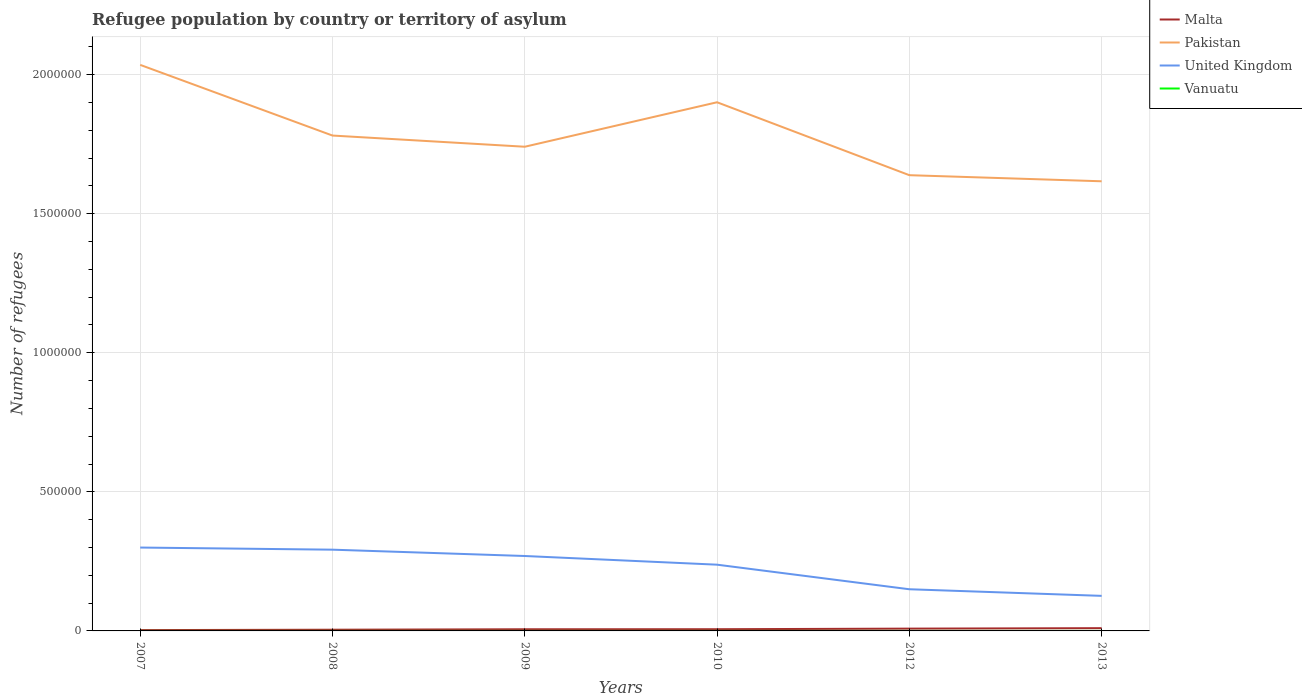How many different coloured lines are there?
Offer a terse response. 4. Does the line corresponding to Pakistan intersect with the line corresponding to Malta?
Your response must be concise. No. Across all years, what is the maximum number of refugees in Malta?
Offer a terse response. 3000. What is the total number of refugees in United Kingdom in the graph?
Offer a terse response. 6.16e+04. What is the difference between the highest and the second highest number of refugees in Pakistan?
Give a very brief answer. 4.19e+05. What is the difference between the highest and the lowest number of refugees in Pakistan?
Provide a short and direct response. 2. Is the number of refugees in United Kingdom strictly greater than the number of refugees in Vanuatu over the years?
Offer a terse response. No. How many lines are there?
Your answer should be very brief. 4. How many years are there in the graph?
Your answer should be compact. 6. Are the values on the major ticks of Y-axis written in scientific E-notation?
Offer a terse response. No. Where does the legend appear in the graph?
Provide a succinct answer. Top right. How are the legend labels stacked?
Keep it short and to the point. Vertical. What is the title of the graph?
Your answer should be very brief. Refugee population by country or territory of asylum. What is the label or title of the X-axis?
Your answer should be compact. Years. What is the label or title of the Y-axis?
Offer a terse response. Number of refugees. What is the Number of refugees in Malta in 2007?
Offer a very short reply. 3000. What is the Number of refugees in Pakistan in 2007?
Provide a short and direct response. 2.04e+06. What is the Number of refugees in United Kingdom in 2007?
Offer a terse response. 3.00e+05. What is the Number of refugees of Vanuatu in 2007?
Your answer should be very brief. 1. What is the Number of refugees of Malta in 2008?
Give a very brief answer. 4332. What is the Number of refugees in Pakistan in 2008?
Keep it short and to the point. 1.78e+06. What is the Number of refugees in United Kingdom in 2008?
Your answer should be very brief. 2.92e+05. What is the Number of refugees in Vanuatu in 2008?
Provide a short and direct response. 3. What is the Number of refugees of Malta in 2009?
Your response must be concise. 5955. What is the Number of refugees in Pakistan in 2009?
Your answer should be very brief. 1.74e+06. What is the Number of refugees of United Kingdom in 2009?
Your answer should be compact. 2.69e+05. What is the Number of refugees in Malta in 2010?
Your answer should be very brief. 6136. What is the Number of refugees of Pakistan in 2010?
Offer a terse response. 1.90e+06. What is the Number of refugees of United Kingdom in 2010?
Offer a very short reply. 2.38e+05. What is the Number of refugees of Malta in 2012?
Your response must be concise. 8248. What is the Number of refugees of Pakistan in 2012?
Provide a short and direct response. 1.64e+06. What is the Number of refugees in United Kingdom in 2012?
Ensure brevity in your answer.  1.50e+05. What is the Number of refugees of Vanuatu in 2012?
Make the answer very short. 2. What is the Number of refugees of Malta in 2013?
Give a very brief answer. 9906. What is the Number of refugees of Pakistan in 2013?
Give a very brief answer. 1.62e+06. What is the Number of refugees of United Kingdom in 2013?
Your answer should be compact. 1.26e+05. Across all years, what is the maximum Number of refugees in Malta?
Provide a short and direct response. 9906. Across all years, what is the maximum Number of refugees in Pakistan?
Offer a terse response. 2.04e+06. Across all years, what is the maximum Number of refugees of United Kingdom?
Provide a succinct answer. 3.00e+05. Across all years, what is the maximum Number of refugees of Vanuatu?
Make the answer very short. 4. Across all years, what is the minimum Number of refugees of Malta?
Ensure brevity in your answer.  3000. Across all years, what is the minimum Number of refugees of Pakistan?
Provide a short and direct response. 1.62e+06. Across all years, what is the minimum Number of refugees of United Kingdom?
Offer a terse response. 1.26e+05. Across all years, what is the minimum Number of refugees in Vanuatu?
Keep it short and to the point. 1. What is the total Number of refugees in Malta in the graph?
Offer a very short reply. 3.76e+04. What is the total Number of refugees of Pakistan in the graph?
Your response must be concise. 1.07e+07. What is the total Number of refugees of United Kingdom in the graph?
Your answer should be compact. 1.38e+06. What is the difference between the Number of refugees in Malta in 2007 and that in 2008?
Provide a short and direct response. -1332. What is the difference between the Number of refugees of Pakistan in 2007 and that in 2008?
Make the answer very short. 2.54e+05. What is the difference between the Number of refugees of United Kingdom in 2007 and that in 2008?
Ensure brevity in your answer.  7621. What is the difference between the Number of refugees in Vanuatu in 2007 and that in 2008?
Offer a terse response. -2. What is the difference between the Number of refugees in Malta in 2007 and that in 2009?
Keep it short and to the point. -2955. What is the difference between the Number of refugees of Pakistan in 2007 and that in 2009?
Your response must be concise. 2.94e+05. What is the difference between the Number of refugees in United Kingdom in 2007 and that in 2009?
Your answer should be very brief. 3.04e+04. What is the difference between the Number of refugees in Vanuatu in 2007 and that in 2009?
Give a very brief answer. -3. What is the difference between the Number of refugees of Malta in 2007 and that in 2010?
Ensure brevity in your answer.  -3136. What is the difference between the Number of refugees of Pakistan in 2007 and that in 2010?
Keep it short and to the point. 1.34e+05. What is the difference between the Number of refugees of United Kingdom in 2007 and that in 2010?
Your answer should be very brief. 6.16e+04. What is the difference between the Number of refugees of Vanuatu in 2007 and that in 2010?
Your response must be concise. -3. What is the difference between the Number of refugees of Malta in 2007 and that in 2012?
Your answer should be very brief. -5248. What is the difference between the Number of refugees of Pakistan in 2007 and that in 2012?
Offer a very short reply. 3.97e+05. What is the difference between the Number of refugees in United Kingdom in 2007 and that in 2012?
Your answer should be very brief. 1.50e+05. What is the difference between the Number of refugees of Malta in 2007 and that in 2013?
Provide a succinct answer. -6906. What is the difference between the Number of refugees in Pakistan in 2007 and that in 2013?
Give a very brief answer. 4.19e+05. What is the difference between the Number of refugees of United Kingdom in 2007 and that in 2013?
Offer a very short reply. 1.74e+05. What is the difference between the Number of refugees of Vanuatu in 2007 and that in 2013?
Your answer should be compact. -1. What is the difference between the Number of refugees in Malta in 2008 and that in 2009?
Your answer should be compact. -1623. What is the difference between the Number of refugees of Pakistan in 2008 and that in 2009?
Offer a terse response. 4.02e+04. What is the difference between the Number of refugees of United Kingdom in 2008 and that in 2009?
Your answer should be very brief. 2.27e+04. What is the difference between the Number of refugees in Vanuatu in 2008 and that in 2009?
Your answer should be compact. -1. What is the difference between the Number of refugees of Malta in 2008 and that in 2010?
Make the answer very short. -1804. What is the difference between the Number of refugees in Pakistan in 2008 and that in 2010?
Give a very brief answer. -1.20e+05. What is the difference between the Number of refugees of United Kingdom in 2008 and that in 2010?
Offer a very short reply. 5.39e+04. What is the difference between the Number of refugees in Vanuatu in 2008 and that in 2010?
Give a very brief answer. -1. What is the difference between the Number of refugees of Malta in 2008 and that in 2012?
Offer a very short reply. -3916. What is the difference between the Number of refugees of Pakistan in 2008 and that in 2012?
Offer a terse response. 1.42e+05. What is the difference between the Number of refugees in United Kingdom in 2008 and that in 2012?
Your answer should be compact. 1.42e+05. What is the difference between the Number of refugees of Malta in 2008 and that in 2013?
Provide a short and direct response. -5574. What is the difference between the Number of refugees in Pakistan in 2008 and that in 2013?
Provide a short and direct response. 1.64e+05. What is the difference between the Number of refugees in United Kingdom in 2008 and that in 2013?
Offer a terse response. 1.66e+05. What is the difference between the Number of refugees of Vanuatu in 2008 and that in 2013?
Provide a short and direct response. 1. What is the difference between the Number of refugees of Malta in 2009 and that in 2010?
Keep it short and to the point. -181. What is the difference between the Number of refugees of Pakistan in 2009 and that in 2010?
Your answer should be very brief. -1.60e+05. What is the difference between the Number of refugees of United Kingdom in 2009 and that in 2010?
Your answer should be compact. 3.12e+04. What is the difference between the Number of refugees of Malta in 2009 and that in 2012?
Provide a short and direct response. -2293. What is the difference between the Number of refugees of Pakistan in 2009 and that in 2012?
Offer a very short reply. 1.02e+05. What is the difference between the Number of refugees of United Kingdom in 2009 and that in 2012?
Ensure brevity in your answer.  1.20e+05. What is the difference between the Number of refugees in Malta in 2009 and that in 2013?
Offer a very short reply. -3951. What is the difference between the Number of refugees of Pakistan in 2009 and that in 2013?
Give a very brief answer. 1.24e+05. What is the difference between the Number of refugees of United Kingdom in 2009 and that in 2013?
Keep it short and to the point. 1.43e+05. What is the difference between the Number of refugees of Malta in 2010 and that in 2012?
Your answer should be compact. -2112. What is the difference between the Number of refugees of Pakistan in 2010 and that in 2012?
Your answer should be very brief. 2.62e+05. What is the difference between the Number of refugees of United Kingdom in 2010 and that in 2012?
Make the answer very short. 8.84e+04. What is the difference between the Number of refugees of Malta in 2010 and that in 2013?
Keep it short and to the point. -3770. What is the difference between the Number of refugees in Pakistan in 2010 and that in 2013?
Provide a short and direct response. 2.84e+05. What is the difference between the Number of refugees in United Kingdom in 2010 and that in 2013?
Your response must be concise. 1.12e+05. What is the difference between the Number of refugees of Vanuatu in 2010 and that in 2013?
Offer a terse response. 2. What is the difference between the Number of refugees in Malta in 2012 and that in 2013?
Ensure brevity in your answer.  -1658. What is the difference between the Number of refugees of Pakistan in 2012 and that in 2013?
Your answer should be compact. 2.19e+04. What is the difference between the Number of refugees in United Kingdom in 2012 and that in 2013?
Ensure brevity in your answer.  2.37e+04. What is the difference between the Number of refugees in Malta in 2007 and the Number of refugees in Pakistan in 2008?
Your answer should be compact. -1.78e+06. What is the difference between the Number of refugees of Malta in 2007 and the Number of refugees of United Kingdom in 2008?
Offer a very short reply. -2.89e+05. What is the difference between the Number of refugees in Malta in 2007 and the Number of refugees in Vanuatu in 2008?
Make the answer very short. 2997. What is the difference between the Number of refugees of Pakistan in 2007 and the Number of refugees of United Kingdom in 2008?
Your answer should be very brief. 1.74e+06. What is the difference between the Number of refugees of Pakistan in 2007 and the Number of refugees of Vanuatu in 2008?
Provide a succinct answer. 2.04e+06. What is the difference between the Number of refugees in United Kingdom in 2007 and the Number of refugees in Vanuatu in 2008?
Provide a succinct answer. 3.00e+05. What is the difference between the Number of refugees in Malta in 2007 and the Number of refugees in Pakistan in 2009?
Make the answer very short. -1.74e+06. What is the difference between the Number of refugees of Malta in 2007 and the Number of refugees of United Kingdom in 2009?
Offer a terse response. -2.66e+05. What is the difference between the Number of refugees in Malta in 2007 and the Number of refugees in Vanuatu in 2009?
Make the answer very short. 2996. What is the difference between the Number of refugees in Pakistan in 2007 and the Number of refugees in United Kingdom in 2009?
Offer a terse response. 1.77e+06. What is the difference between the Number of refugees in Pakistan in 2007 and the Number of refugees in Vanuatu in 2009?
Offer a very short reply. 2.04e+06. What is the difference between the Number of refugees of United Kingdom in 2007 and the Number of refugees of Vanuatu in 2009?
Your answer should be very brief. 3.00e+05. What is the difference between the Number of refugees in Malta in 2007 and the Number of refugees in Pakistan in 2010?
Your answer should be very brief. -1.90e+06. What is the difference between the Number of refugees of Malta in 2007 and the Number of refugees of United Kingdom in 2010?
Offer a terse response. -2.35e+05. What is the difference between the Number of refugees of Malta in 2007 and the Number of refugees of Vanuatu in 2010?
Provide a short and direct response. 2996. What is the difference between the Number of refugees in Pakistan in 2007 and the Number of refugees in United Kingdom in 2010?
Ensure brevity in your answer.  1.80e+06. What is the difference between the Number of refugees in Pakistan in 2007 and the Number of refugees in Vanuatu in 2010?
Your response must be concise. 2.04e+06. What is the difference between the Number of refugees in United Kingdom in 2007 and the Number of refugees in Vanuatu in 2010?
Keep it short and to the point. 3.00e+05. What is the difference between the Number of refugees in Malta in 2007 and the Number of refugees in Pakistan in 2012?
Your response must be concise. -1.64e+06. What is the difference between the Number of refugees in Malta in 2007 and the Number of refugees in United Kingdom in 2012?
Offer a very short reply. -1.47e+05. What is the difference between the Number of refugees in Malta in 2007 and the Number of refugees in Vanuatu in 2012?
Offer a terse response. 2998. What is the difference between the Number of refugees in Pakistan in 2007 and the Number of refugees in United Kingdom in 2012?
Offer a very short reply. 1.89e+06. What is the difference between the Number of refugees of Pakistan in 2007 and the Number of refugees of Vanuatu in 2012?
Your answer should be very brief. 2.04e+06. What is the difference between the Number of refugees in United Kingdom in 2007 and the Number of refugees in Vanuatu in 2012?
Ensure brevity in your answer.  3.00e+05. What is the difference between the Number of refugees of Malta in 2007 and the Number of refugees of Pakistan in 2013?
Your response must be concise. -1.61e+06. What is the difference between the Number of refugees of Malta in 2007 and the Number of refugees of United Kingdom in 2013?
Offer a terse response. -1.23e+05. What is the difference between the Number of refugees in Malta in 2007 and the Number of refugees in Vanuatu in 2013?
Ensure brevity in your answer.  2998. What is the difference between the Number of refugees in Pakistan in 2007 and the Number of refugees in United Kingdom in 2013?
Ensure brevity in your answer.  1.91e+06. What is the difference between the Number of refugees in Pakistan in 2007 and the Number of refugees in Vanuatu in 2013?
Your answer should be very brief. 2.04e+06. What is the difference between the Number of refugees of United Kingdom in 2007 and the Number of refugees of Vanuatu in 2013?
Keep it short and to the point. 3.00e+05. What is the difference between the Number of refugees in Malta in 2008 and the Number of refugees in Pakistan in 2009?
Your answer should be compact. -1.74e+06. What is the difference between the Number of refugees in Malta in 2008 and the Number of refugees in United Kingdom in 2009?
Your response must be concise. -2.65e+05. What is the difference between the Number of refugees in Malta in 2008 and the Number of refugees in Vanuatu in 2009?
Provide a succinct answer. 4328. What is the difference between the Number of refugees in Pakistan in 2008 and the Number of refugees in United Kingdom in 2009?
Keep it short and to the point. 1.51e+06. What is the difference between the Number of refugees in Pakistan in 2008 and the Number of refugees in Vanuatu in 2009?
Provide a succinct answer. 1.78e+06. What is the difference between the Number of refugees in United Kingdom in 2008 and the Number of refugees in Vanuatu in 2009?
Your response must be concise. 2.92e+05. What is the difference between the Number of refugees in Malta in 2008 and the Number of refugees in Pakistan in 2010?
Provide a short and direct response. -1.90e+06. What is the difference between the Number of refugees of Malta in 2008 and the Number of refugees of United Kingdom in 2010?
Your answer should be very brief. -2.34e+05. What is the difference between the Number of refugees in Malta in 2008 and the Number of refugees in Vanuatu in 2010?
Offer a very short reply. 4328. What is the difference between the Number of refugees in Pakistan in 2008 and the Number of refugees in United Kingdom in 2010?
Give a very brief answer. 1.54e+06. What is the difference between the Number of refugees in Pakistan in 2008 and the Number of refugees in Vanuatu in 2010?
Make the answer very short. 1.78e+06. What is the difference between the Number of refugees in United Kingdom in 2008 and the Number of refugees in Vanuatu in 2010?
Make the answer very short. 2.92e+05. What is the difference between the Number of refugees in Malta in 2008 and the Number of refugees in Pakistan in 2012?
Your response must be concise. -1.63e+06. What is the difference between the Number of refugees in Malta in 2008 and the Number of refugees in United Kingdom in 2012?
Provide a succinct answer. -1.45e+05. What is the difference between the Number of refugees of Malta in 2008 and the Number of refugees of Vanuatu in 2012?
Ensure brevity in your answer.  4330. What is the difference between the Number of refugees in Pakistan in 2008 and the Number of refugees in United Kingdom in 2012?
Keep it short and to the point. 1.63e+06. What is the difference between the Number of refugees of Pakistan in 2008 and the Number of refugees of Vanuatu in 2012?
Your response must be concise. 1.78e+06. What is the difference between the Number of refugees of United Kingdom in 2008 and the Number of refugees of Vanuatu in 2012?
Provide a succinct answer. 2.92e+05. What is the difference between the Number of refugees in Malta in 2008 and the Number of refugees in Pakistan in 2013?
Make the answer very short. -1.61e+06. What is the difference between the Number of refugees in Malta in 2008 and the Number of refugees in United Kingdom in 2013?
Offer a terse response. -1.22e+05. What is the difference between the Number of refugees in Malta in 2008 and the Number of refugees in Vanuatu in 2013?
Offer a very short reply. 4330. What is the difference between the Number of refugees of Pakistan in 2008 and the Number of refugees of United Kingdom in 2013?
Provide a short and direct response. 1.65e+06. What is the difference between the Number of refugees in Pakistan in 2008 and the Number of refugees in Vanuatu in 2013?
Ensure brevity in your answer.  1.78e+06. What is the difference between the Number of refugees of United Kingdom in 2008 and the Number of refugees of Vanuatu in 2013?
Ensure brevity in your answer.  2.92e+05. What is the difference between the Number of refugees of Malta in 2009 and the Number of refugees of Pakistan in 2010?
Offer a terse response. -1.89e+06. What is the difference between the Number of refugees in Malta in 2009 and the Number of refugees in United Kingdom in 2010?
Offer a terse response. -2.32e+05. What is the difference between the Number of refugees of Malta in 2009 and the Number of refugees of Vanuatu in 2010?
Your response must be concise. 5951. What is the difference between the Number of refugees of Pakistan in 2009 and the Number of refugees of United Kingdom in 2010?
Give a very brief answer. 1.50e+06. What is the difference between the Number of refugees in Pakistan in 2009 and the Number of refugees in Vanuatu in 2010?
Make the answer very short. 1.74e+06. What is the difference between the Number of refugees of United Kingdom in 2009 and the Number of refugees of Vanuatu in 2010?
Your answer should be very brief. 2.69e+05. What is the difference between the Number of refugees of Malta in 2009 and the Number of refugees of Pakistan in 2012?
Provide a succinct answer. -1.63e+06. What is the difference between the Number of refugees of Malta in 2009 and the Number of refugees of United Kingdom in 2012?
Ensure brevity in your answer.  -1.44e+05. What is the difference between the Number of refugees in Malta in 2009 and the Number of refugees in Vanuatu in 2012?
Make the answer very short. 5953. What is the difference between the Number of refugees of Pakistan in 2009 and the Number of refugees of United Kingdom in 2012?
Provide a succinct answer. 1.59e+06. What is the difference between the Number of refugees in Pakistan in 2009 and the Number of refugees in Vanuatu in 2012?
Provide a short and direct response. 1.74e+06. What is the difference between the Number of refugees of United Kingdom in 2009 and the Number of refugees of Vanuatu in 2012?
Offer a terse response. 2.69e+05. What is the difference between the Number of refugees in Malta in 2009 and the Number of refugees in Pakistan in 2013?
Provide a succinct answer. -1.61e+06. What is the difference between the Number of refugees in Malta in 2009 and the Number of refugees in United Kingdom in 2013?
Your response must be concise. -1.20e+05. What is the difference between the Number of refugees of Malta in 2009 and the Number of refugees of Vanuatu in 2013?
Your answer should be compact. 5953. What is the difference between the Number of refugees in Pakistan in 2009 and the Number of refugees in United Kingdom in 2013?
Give a very brief answer. 1.61e+06. What is the difference between the Number of refugees in Pakistan in 2009 and the Number of refugees in Vanuatu in 2013?
Offer a terse response. 1.74e+06. What is the difference between the Number of refugees in United Kingdom in 2009 and the Number of refugees in Vanuatu in 2013?
Offer a very short reply. 2.69e+05. What is the difference between the Number of refugees in Malta in 2010 and the Number of refugees in Pakistan in 2012?
Your answer should be very brief. -1.63e+06. What is the difference between the Number of refugees of Malta in 2010 and the Number of refugees of United Kingdom in 2012?
Offer a terse response. -1.44e+05. What is the difference between the Number of refugees of Malta in 2010 and the Number of refugees of Vanuatu in 2012?
Ensure brevity in your answer.  6134. What is the difference between the Number of refugees of Pakistan in 2010 and the Number of refugees of United Kingdom in 2012?
Keep it short and to the point. 1.75e+06. What is the difference between the Number of refugees of Pakistan in 2010 and the Number of refugees of Vanuatu in 2012?
Make the answer very short. 1.90e+06. What is the difference between the Number of refugees in United Kingdom in 2010 and the Number of refugees in Vanuatu in 2012?
Offer a terse response. 2.38e+05. What is the difference between the Number of refugees of Malta in 2010 and the Number of refugees of Pakistan in 2013?
Provide a succinct answer. -1.61e+06. What is the difference between the Number of refugees in Malta in 2010 and the Number of refugees in United Kingdom in 2013?
Make the answer very short. -1.20e+05. What is the difference between the Number of refugees of Malta in 2010 and the Number of refugees of Vanuatu in 2013?
Provide a short and direct response. 6134. What is the difference between the Number of refugees in Pakistan in 2010 and the Number of refugees in United Kingdom in 2013?
Ensure brevity in your answer.  1.77e+06. What is the difference between the Number of refugees in Pakistan in 2010 and the Number of refugees in Vanuatu in 2013?
Your answer should be compact. 1.90e+06. What is the difference between the Number of refugees in United Kingdom in 2010 and the Number of refugees in Vanuatu in 2013?
Your answer should be compact. 2.38e+05. What is the difference between the Number of refugees of Malta in 2012 and the Number of refugees of Pakistan in 2013?
Provide a short and direct response. -1.61e+06. What is the difference between the Number of refugees of Malta in 2012 and the Number of refugees of United Kingdom in 2013?
Keep it short and to the point. -1.18e+05. What is the difference between the Number of refugees of Malta in 2012 and the Number of refugees of Vanuatu in 2013?
Offer a very short reply. 8246. What is the difference between the Number of refugees in Pakistan in 2012 and the Number of refugees in United Kingdom in 2013?
Your response must be concise. 1.51e+06. What is the difference between the Number of refugees of Pakistan in 2012 and the Number of refugees of Vanuatu in 2013?
Provide a succinct answer. 1.64e+06. What is the difference between the Number of refugees in United Kingdom in 2012 and the Number of refugees in Vanuatu in 2013?
Keep it short and to the point. 1.50e+05. What is the average Number of refugees in Malta per year?
Offer a very short reply. 6262.83. What is the average Number of refugees in Pakistan per year?
Offer a terse response. 1.79e+06. What is the average Number of refugees of United Kingdom per year?
Your response must be concise. 2.29e+05. What is the average Number of refugees in Vanuatu per year?
Offer a very short reply. 2.67. In the year 2007, what is the difference between the Number of refugees in Malta and Number of refugees in Pakistan?
Offer a terse response. -2.03e+06. In the year 2007, what is the difference between the Number of refugees in Malta and Number of refugees in United Kingdom?
Provide a succinct answer. -2.97e+05. In the year 2007, what is the difference between the Number of refugees of Malta and Number of refugees of Vanuatu?
Your answer should be very brief. 2999. In the year 2007, what is the difference between the Number of refugees of Pakistan and Number of refugees of United Kingdom?
Make the answer very short. 1.74e+06. In the year 2007, what is the difference between the Number of refugees in Pakistan and Number of refugees in Vanuatu?
Keep it short and to the point. 2.04e+06. In the year 2007, what is the difference between the Number of refugees of United Kingdom and Number of refugees of Vanuatu?
Offer a very short reply. 3.00e+05. In the year 2008, what is the difference between the Number of refugees in Malta and Number of refugees in Pakistan?
Offer a terse response. -1.78e+06. In the year 2008, what is the difference between the Number of refugees of Malta and Number of refugees of United Kingdom?
Give a very brief answer. -2.88e+05. In the year 2008, what is the difference between the Number of refugees in Malta and Number of refugees in Vanuatu?
Make the answer very short. 4329. In the year 2008, what is the difference between the Number of refugees in Pakistan and Number of refugees in United Kingdom?
Ensure brevity in your answer.  1.49e+06. In the year 2008, what is the difference between the Number of refugees of Pakistan and Number of refugees of Vanuatu?
Your response must be concise. 1.78e+06. In the year 2008, what is the difference between the Number of refugees of United Kingdom and Number of refugees of Vanuatu?
Offer a terse response. 2.92e+05. In the year 2009, what is the difference between the Number of refugees in Malta and Number of refugees in Pakistan?
Your answer should be compact. -1.73e+06. In the year 2009, what is the difference between the Number of refugees of Malta and Number of refugees of United Kingdom?
Offer a terse response. -2.63e+05. In the year 2009, what is the difference between the Number of refugees of Malta and Number of refugees of Vanuatu?
Keep it short and to the point. 5951. In the year 2009, what is the difference between the Number of refugees of Pakistan and Number of refugees of United Kingdom?
Provide a succinct answer. 1.47e+06. In the year 2009, what is the difference between the Number of refugees of Pakistan and Number of refugees of Vanuatu?
Ensure brevity in your answer.  1.74e+06. In the year 2009, what is the difference between the Number of refugees of United Kingdom and Number of refugees of Vanuatu?
Offer a terse response. 2.69e+05. In the year 2010, what is the difference between the Number of refugees in Malta and Number of refugees in Pakistan?
Your answer should be compact. -1.89e+06. In the year 2010, what is the difference between the Number of refugees in Malta and Number of refugees in United Kingdom?
Give a very brief answer. -2.32e+05. In the year 2010, what is the difference between the Number of refugees in Malta and Number of refugees in Vanuatu?
Offer a terse response. 6132. In the year 2010, what is the difference between the Number of refugees of Pakistan and Number of refugees of United Kingdom?
Offer a terse response. 1.66e+06. In the year 2010, what is the difference between the Number of refugees in Pakistan and Number of refugees in Vanuatu?
Provide a succinct answer. 1.90e+06. In the year 2010, what is the difference between the Number of refugees in United Kingdom and Number of refugees in Vanuatu?
Your response must be concise. 2.38e+05. In the year 2012, what is the difference between the Number of refugees in Malta and Number of refugees in Pakistan?
Give a very brief answer. -1.63e+06. In the year 2012, what is the difference between the Number of refugees of Malta and Number of refugees of United Kingdom?
Provide a succinct answer. -1.42e+05. In the year 2012, what is the difference between the Number of refugees in Malta and Number of refugees in Vanuatu?
Make the answer very short. 8246. In the year 2012, what is the difference between the Number of refugees in Pakistan and Number of refugees in United Kingdom?
Make the answer very short. 1.49e+06. In the year 2012, what is the difference between the Number of refugees in Pakistan and Number of refugees in Vanuatu?
Ensure brevity in your answer.  1.64e+06. In the year 2012, what is the difference between the Number of refugees of United Kingdom and Number of refugees of Vanuatu?
Your response must be concise. 1.50e+05. In the year 2013, what is the difference between the Number of refugees in Malta and Number of refugees in Pakistan?
Keep it short and to the point. -1.61e+06. In the year 2013, what is the difference between the Number of refugees of Malta and Number of refugees of United Kingdom?
Give a very brief answer. -1.16e+05. In the year 2013, what is the difference between the Number of refugees of Malta and Number of refugees of Vanuatu?
Offer a terse response. 9904. In the year 2013, what is the difference between the Number of refugees of Pakistan and Number of refugees of United Kingdom?
Provide a short and direct response. 1.49e+06. In the year 2013, what is the difference between the Number of refugees in Pakistan and Number of refugees in Vanuatu?
Give a very brief answer. 1.62e+06. In the year 2013, what is the difference between the Number of refugees in United Kingdom and Number of refugees in Vanuatu?
Give a very brief answer. 1.26e+05. What is the ratio of the Number of refugees of Malta in 2007 to that in 2008?
Keep it short and to the point. 0.69. What is the ratio of the Number of refugees in Pakistan in 2007 to that in 2008?
Offer a terse response. 1.14. What is the ratio of the Number of refugees in United Kingdom in 2007 to that in 2008?
Provide a succinct answer. 1.03. What is the ratio of the Number of refugees of Malta in 2007 to that in 2009?
Keep it short and to the point. 0.5. What is the ratio of the Number of refugees of Pakistan in 2007 to that in 2009?
Provide a short and direct response. 1.17. What is the ratio of the Number of refugees in United Kingdom in 2007 to that in 2009?
Give a very brief answer. 1.11. What is the ratio of the Number of refugees of Malta in 2007 to that in 2010?
Offer a very short reply. 0.49. What is the ratio of the Number of refugees of Pakistan in 2007 to that in 2010?
Provide a short and direct response. 1.07. What is the ratio of the Number of refugees in United Kingdom in 2007 to that in 2010?
Your answer should be compact. 1.26. What is the ratio of the Number of refugees in Vanuatu in 2007 to that in 2010?
Give a very brief answer. 0.25. What is the ratio of the Number of refugees in Malta in 2007 to that in 2012?
Offer a terse response. 0.36. What is the ratio of the Number of refugees of Pakistan in 2007 to that in 2012?
Ensure brevity in your answer.  1.24. What is the ratio of the Number of refugees in United Kingdom in 2007 to that in 2012?
Provide a short and direct response. 2. What is the ratio of the Number of refugees in Malta in 2007 to that in 2013?
Your answer should be compact. 0.3. What is the ratio of the Number of refugees in Pakistan in 2007 to that in 2013?
Your answer should be compact. 1.26. What is the ratio of the Number of refugees in United Kingdom in 2007 to that in 2013?
Offer a very short reply. 2.38. What is the ratio of the Number of refugees in Malta in 2008 to that in 2009?
Provide a short and direct response. 0.73. What is the ratio of the Number of refugees of Pakistan in 2008 to that in 2009?
Offer a very short reply. 1.02. What is the ratio of the Number of refugees of United Kingdom in 2008 to that in 2009?
Offer a very short reply. 1.08. What is the ratio of the Number of refugees of Malta in 2008 to that in 2010?
Provide a succinct answer. 0.71. What is the ratio of the Number of refugees in Pakistan in 2008 to that in 2010?
Your response must be concise. 0.94. What is the ratio of the Number of refugees in United Kingdom in 2008 to that in 2010?
Give a very brief answer. 1.23. What is the ratio of the Number of refugees of Vanuatu in 2008 to that in 2010?
Make the answer very short. 0.75. What is the ratio of the Number of refugees in Malta in 2008 to that in 2012?
Offer a very short reply. 0.53. What is the ratio of the Number of refugees in Pakistan in 2008 to that in 2012?
Provide a short and direct response. 1.09. What is the ratio of the Number of refugees of United Kingdom in 2008 to that in 2012?
Keep it short and to the point. 1.95. What is the ratio of the Number of refugees in Malta in 2008 to that in 2013?
Keep it short and to the point. 0.44. What is the ratio of the Number of refugees of Pakistan in 2008 to that in 2013?
Provide a succinct answer. 1.1. What is the ratio of the Number of refugees of United Kingdom in 2008 to that in 2013?
Provide a succinct answer. 2.32. What is the ratio of the Number of refugees of Malta in 2009 to that in 2010?
Your answer should be very brief. 0.97. What is the ratio of the Number of refugees of Pakistan in 2009 to that in 2010?
Give a very brief answer. 0.92. What is the ratio of the Number of refugees of United Kingdom in 2009 to that in 2010?
Offer a very short reply. 1.13. What is the ratio of the Number of refugees of Malta in 2009 to that in 2012?
Your answer should be very brief. 0.72. What is the ratio of the Number of refugees in Pakistan in 2009 to that in 2012?
Ensure brevity in your answer.  1.06. What is the ratio of the Number of refugees of United Kingdom in 2009 to that in 2012?
Ensure brevity in your answer.  1.8. What is the ratio of the Number of refugees of Vanuatu in 2009 to that in 2012?
Provide a short and direct response. 2. What is the ratio of the Number of refugees of Malta in 2009 to that in 2013?
Offer a very short reply. 0.6. What is the ratio of the Number of refugees of Pakistan in 2009 to that in 2013?
Your answer should be compact. 1.08. What is the ratio of the Number of refugees of United Kingdom in 2009 to that in 2013?
Give a very brief answer. 2.14. What is the ratio of the Number of refugees in Malta in 2010 to that in 2012?
Provide a short and direct response. 0.74. What is the ratio of the Number of refugees in Pakistan in 2010 to that in 2012?
Your answer should be compact. 1.16. What is the ratio of the Number of refugees in United Kingdom in 2010 to that in 2012?
Ensure brevity in your answer.  1.59. What is the ratio of the Number of refugees in Malta in 2010 to that in 2013?
Your answer should be very brief. 0.62. What is the ratio of the Number of refugees of Pakistan in 2010 to that in 2013?
Your answer should be very brief. 1.18. What is the ratio of the Number of refugees of United Kingdom in 2010 to that in 2013?
Offer a very short reply. 1.89. What is the ratio of the Number of refugees in Malta in 2012 to that in 2013?
Give a very brief answer. 0.83. What is the ratio of the Number of refugees of Pakistan in 2012 to that in 2013?
Your response must be concise. 1.01. What is the ratio of the Number of refugees of United Kingdom in 2012 to that in 2013?
Your response must be concise. 1.19. What is the difference between the highest and the second highest Number of refugees in Malta?
Your answer should be compact. 1658. What is the difference between the highest and the second highest Number of refugees of Pakistan?
Offer a very short reply. 1.34e+05. What is the difference between the highest and the second highest Number of refugees in United Kingdom?
Give a very brief answer. 7621. What is the difference between the highest and the lowest Number of refugees in Malta?
Give a very brief answer. 6906. What is the difference between the highest and the lowest Number of refugees of Pakistan?
Your answer should be compact. 4.19e+05. What is the difference between the highest and the lowest Number of refugees of United Kingdom?
Give a very brief answer. 1.74e+05. 